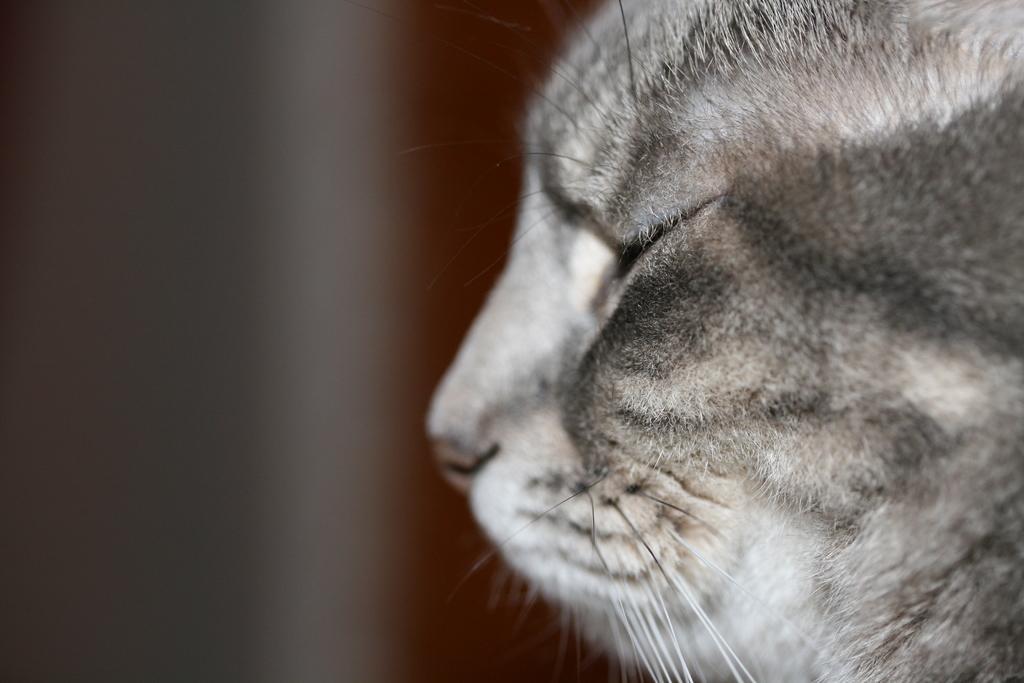How would you summarize this image in a sentence or two? This is a zoomed in picture. On the right we can see the face of an animal. The background of the image is blur. 